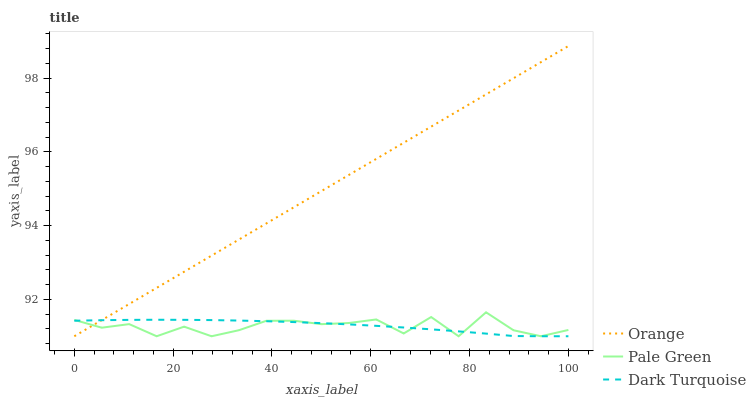Does Pale Green have the minimum area under the curve?
Answer yes or no. Yes. Does Orange have the maximum area under the curve?
Answer yes or no. Yes. Does Dark Turquoise have the minimum area under the curve?
Answer yes or no. No. Does Dark Turquoise have the maximum area under the curve?
Answer yes or no. No. Is Orange the smoothest?
Answer yes or no. Yes. Is Pale Green the roughest?
Answer yes or no. Yes. Is Dark Turquoise the smoothest?
Answer yes or no. No. Is Dark Turquoise the roughest?
Answer yes or no. No. Does Orange have the lowest value?
Answer yes or no. Yes. Does Orange have the highest value?
Answer yes or no. Yes. Does Pale Green have the highest value?
Answer yes or no. No. Does Orange intersect Pale Green?
Answer yes or no. Yes. Is Orange less than Pale Green?
Answer yes or no. No. Is Orange greater than Pale Green?
Answer yes or no. No. 